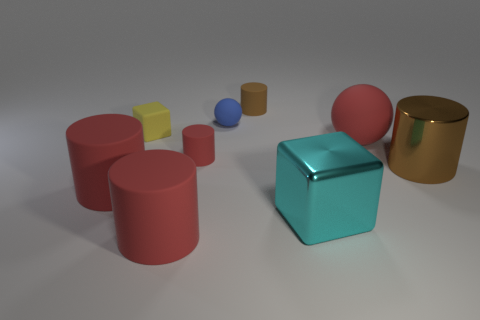How many red cylinders must be subtracted to get 1 red cylinders? 2 Add 1 brown rubber spheres. How many objects exist? 10 Subtract all brown shiny cylinders. How many cylinders are left? 4 Subtract 1 blocks. How many blocks are left? 1 Subtract all red cylinders. How many cylinders are left? 2 Subtract all cylinders. How many objects are left? 4 Subtract all green cylinders. Subtract all purple cubes. How many cylinders are left? 5 Subtract all purple cylinders. How many red balls are left? 1 Subtract all metallic things. Subtract all large cylinders. How many objects are left? 4 Add 6 tiny yellow objects. How many tiny yellow objects are left? 7 